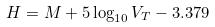<formula> <loc_0><loc_0><loc_500><loc_500>H = M + 5 \log _ { 1 0 } V _ { T } - 3 . 3 7 9</formula> 